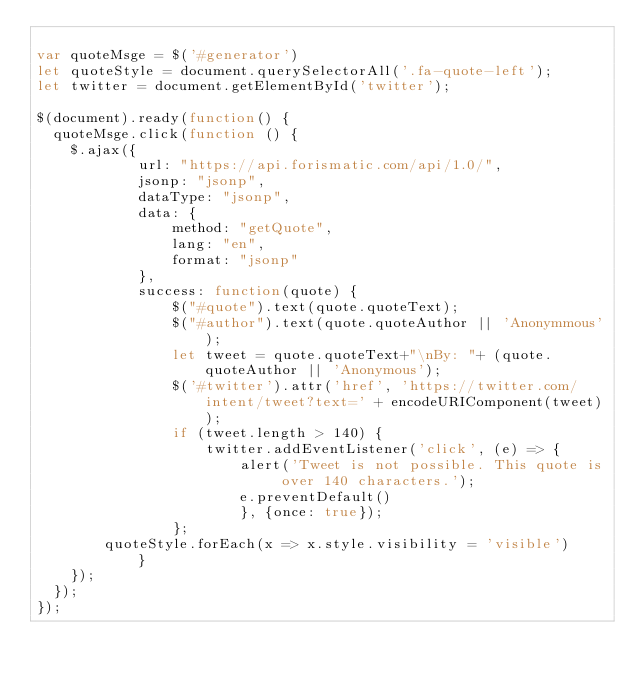<code> <loc_0><loc_0><loc_500><loc_500><_JavaScript_>
var quoteMsge = $('#generator')
let quoteStyle = document.querySelectorAll('.fa-quote-left');
let twitter = document.getElementById('twitter');

$(document).ready(function() {
  quoteMsge.click(function () {
    $.ajax({
			url: "https://api.forismatic.com/api/1.0/",
			jsonp: "jsonp",
			dataType: "jsonp",
			data: {
				method: "getQuote",
				lang: "en",
				format: "jsonp"
			},
			success: function(quote) {
				$("#quote").text(quote.quoteText);
				$("#author").text(quote.quoteAuthor || 'Anonymmous');
				let tweet = quote.quoteText+"\nBy: "+ (quote.quoteAuthor || 'Anonymous');
				$('#twitter').attr('href', 'https://twitter.com/intent/tweet?text=' + encodeURIComponent(tweet));  
				if (tweet.length > 140) {
					twitter.addEventListener('click', (e) => {
						alert('Tweet is not possible. This quote is over 140 characters.'); 
						e.preventDefault()
						}, {once: true});
				};
        quoteStyle.forEach(x => x.style.visibility = 'visible')
			}
    });
  });
});

</code> 